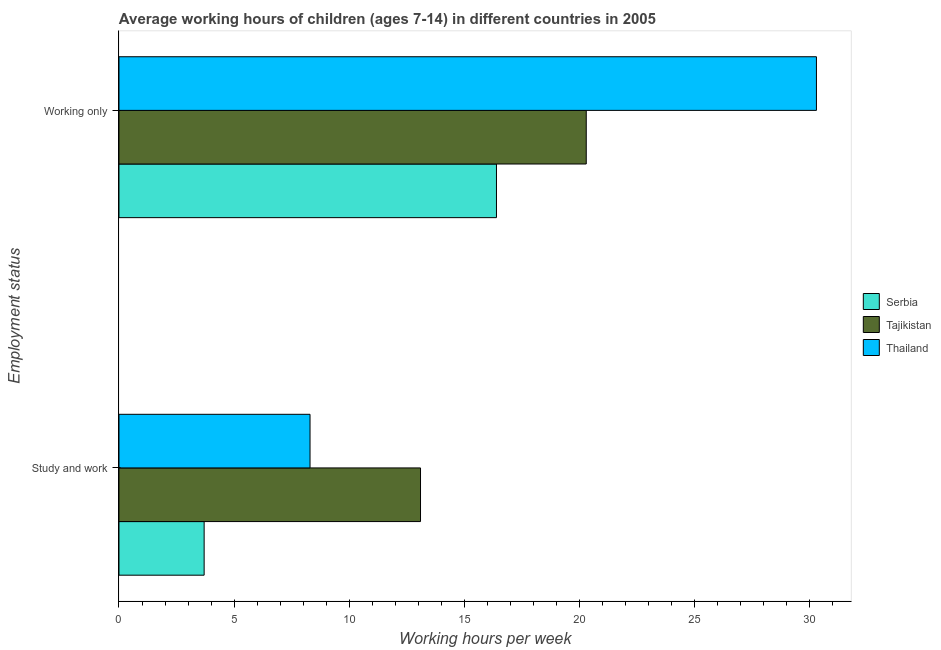How many different coloured bars are there?
Offer a very short reply. 3. How many groups of bars are there?
Your answer should be very brief. 2. How many bars are there on the 1st tick from the top?
Ensure brevity in your answer.  3. What is the label of the 1st group of bars from the top?
Offer a very short reply. Working only. Across all countries, what is the maximum average working hour of children involved in study and work?
Offer a terse response. 13.1. Across all countries, what is the minimum average working hour of children involved in only work?
Your answer should be compact. 16.4. In which country was the average working hour of children involved in study and work maximum?
Ensure brevity in your answer.  Tajikistan. In which country was the average working hour of children involved in only work minimum?
Provide a short and direct response. Serbia. What is the difference between the average working hour of children involved in study and work in Tajikistan and that in Thailand?
Offer a terse response. 4.8. What is the difference between the average working hour of children involved in only work in Thailand and the average working hour of children involved in study and work in Serbia?
Provide a succinct answer. 26.6. What is the average average working hour of children involved in study and work per country?
Make the answer very short. 8.37. In how many countries, is the average working hour of children involved in only work greater than 23 hours?
Offer a terse response. 1. What is the ratio of the average working hour of children involved in only work in Thailand to that in Serbia?
Your response must be concise. 1.85. Is the average working hour of children involved in only work in Tajikistan less than that in Thailand?
Ensure brevity in your answer.  Yes. What does the 2nd bar from the top in Study and work represents?
Offer a very short reply. Tajikistan. What does the 1st bar from the bottom in Study and work represents?
Your answer should be very brief. Serbia. Does the graph contain any zero values?
Your answer should be very brief. No. Does the graph contain grids?
Provide a short and direct response. No. What is the title of the graph?
Your answer should be very brief. Average working hours of children (ages 7-14) in different countries in 2005. Does "Armenia" appear as one of the legend labels in the graph?
Your answer should be very brief. No. What is the label or title of the X-axis?
Offer a terse response. Working hours per week. What is the label or title of the Y-axis?
Provide a succinct answer. Employment status. What is the Working hours per week of Serbia in Study and work?
Provide a succinct answer. 3.7. What is the Working hours per week in Tajikistan in Study and work?
Keep it short and to the point. 13.1. What is the Working hours per week of Tajikistan in Working only?
Your response must be concise. 20.3. What is the Working hours per week in Thailand in Working only?
Offer a terse response. 30.3. Across all Employment status, what is the maximum Working hours per week of Tajikistan?
Keep it short and to the point. 20.3. Across all Employment status, what is the maximum Working hours per week of Thailand?
Your answer should be compact. 30.3. Across all Employment status, what is the minimum Working hours per week of Serbia?
Give a very brief answer. 3.7. What is the total Working hours per week of Serbia in the graph?
Your answer should be compact. 20.1. What is the total Working hours per week in Tajikistan in the graph?
Your answer should be very brief. 33.4. What is the total Working hours per week in Thailand in the graph?
Ensure brevity in your answer.  38.6. What is the difference between the Working hours per week in Serbia in Study and work and that in Working only?
Make the answer very short. -12.7. What is the difference between the Working hours per week in Serbia in Study and work and the Working hours per week in Tajikistan in Working only?
Your response must be concise. -16.6. What is the difference between the Working hours per week in Serbia in Study and work and the Working hours per week in Thailand in Working only?
Your response must be concise. -26.6. What is the difference between the Working hours per week in Tajikistan in Study and work and the Working hours per week in Thailand in Working only?
Give a very brief answer. -17.2. What is the average Working hours per week of Serbia per Employment status?
Provide a succinct answer. 10.05. What is the average Working hours per week in Tajikistan per Employment status?
Ensure brevity in your answer.  16.7. What is the average Working hours per week of Thailand per Employment status?
Give a very brief answer. 19.3. What is the difference between the Working hours per week of Serbia and Working hours per week of Thailand in Study and work?
Keep it short and to the point. -4.6. What is the difference between the Working hours per week in Serbia and Working hours per week in Tajikistan in Working only?
Offer a very short reply. -3.9. What is the difference between the Working hours per week of Serbia and Working hours per week of Thailand in Working only?
Provide a succinct answer. -13.9. What is the ratio of the Working hours per week of Serbia in Study and work to that in Working only?
Your answer should be compact. 0.23. What is the ratio of the Working hours per week in Tajikistan in Study and work to that in Working only?
Provide a short and direct response. 0.65. What is the ratio of the Working hours per week of Thailand in Study and work to that in Working only?
Keep it short and to the point. 0.27. What is the difference between the highest and the second highest Working hours per week of Serbia?
Offer a terse response. 12.7. What is the difference between the highest and the second highest Working hours per week of Thailand?
Offer a terse response. 22. 